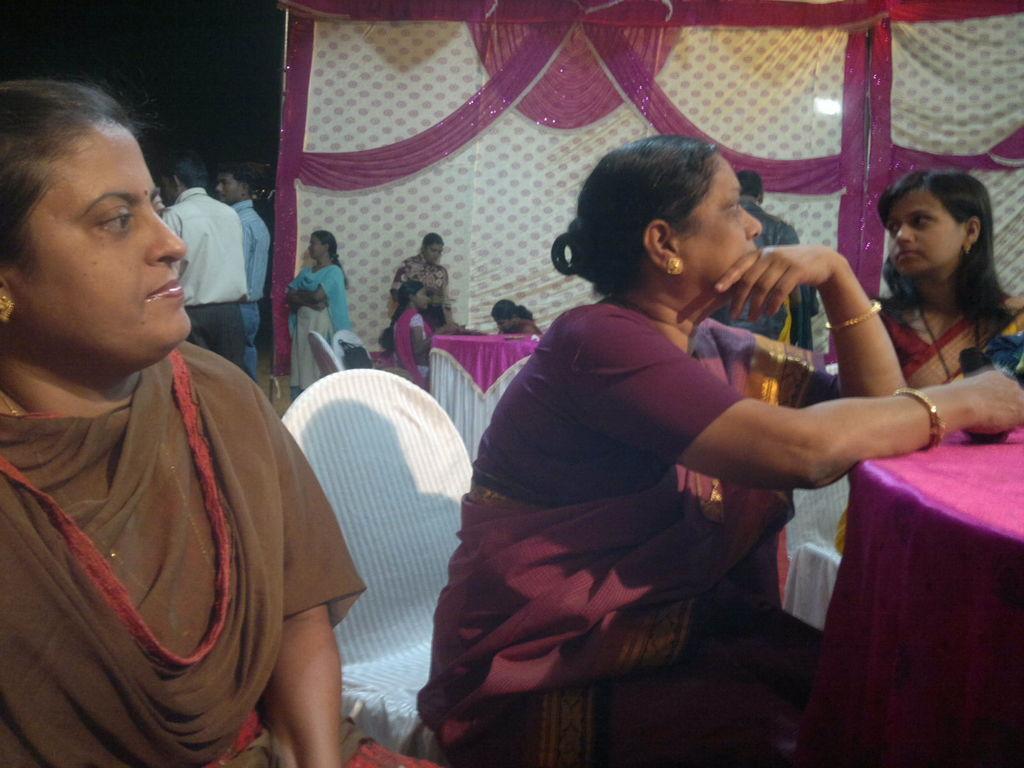Could you give a brief overview of what you see in this image? This image is taken indoors. In the background there are a few curtains. Two men and two women are standing on the floor. In this image a few women are sitting on the chairs and there are a few tables with tablecloths. 